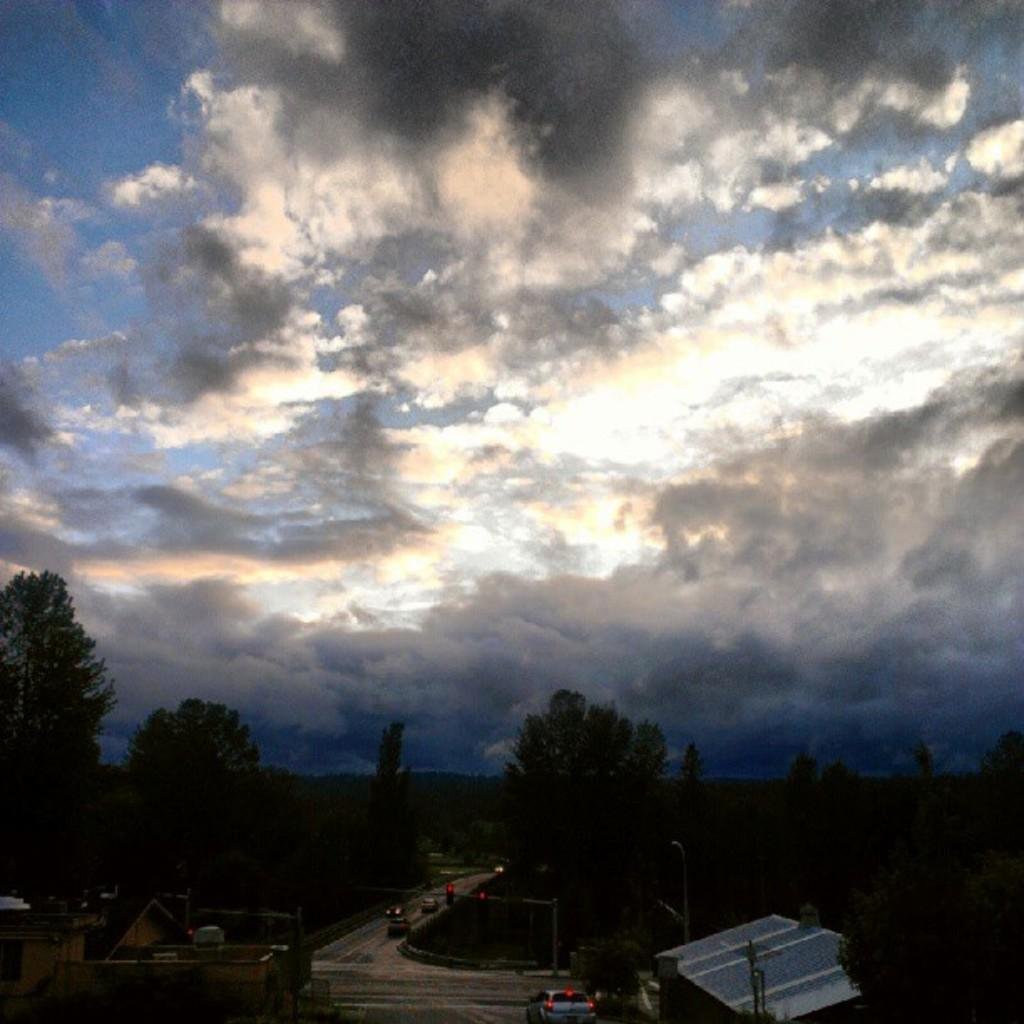What is the condition of the sky in the image? The sky in the image is cloudy. What can be seen at the bottom of the image? There are trees, houses, roads, vehicles, and poles at the bottom of the image. How many types of structures are present at the bottom of the image? There are three types of structures: houses, poles, and trees. What is the purpose of the poles at the bottom of the image? The purpose of the poles is not explicitly mentioned, but they could be for supporting power lines or street lights. What type of quince is being offered as a gift in the image? There is no quince or any indication of a gift being offered in the image. What type of jewel can be seen on the vehicles in the image? There are no jewels visible on the vehicles in the image. 